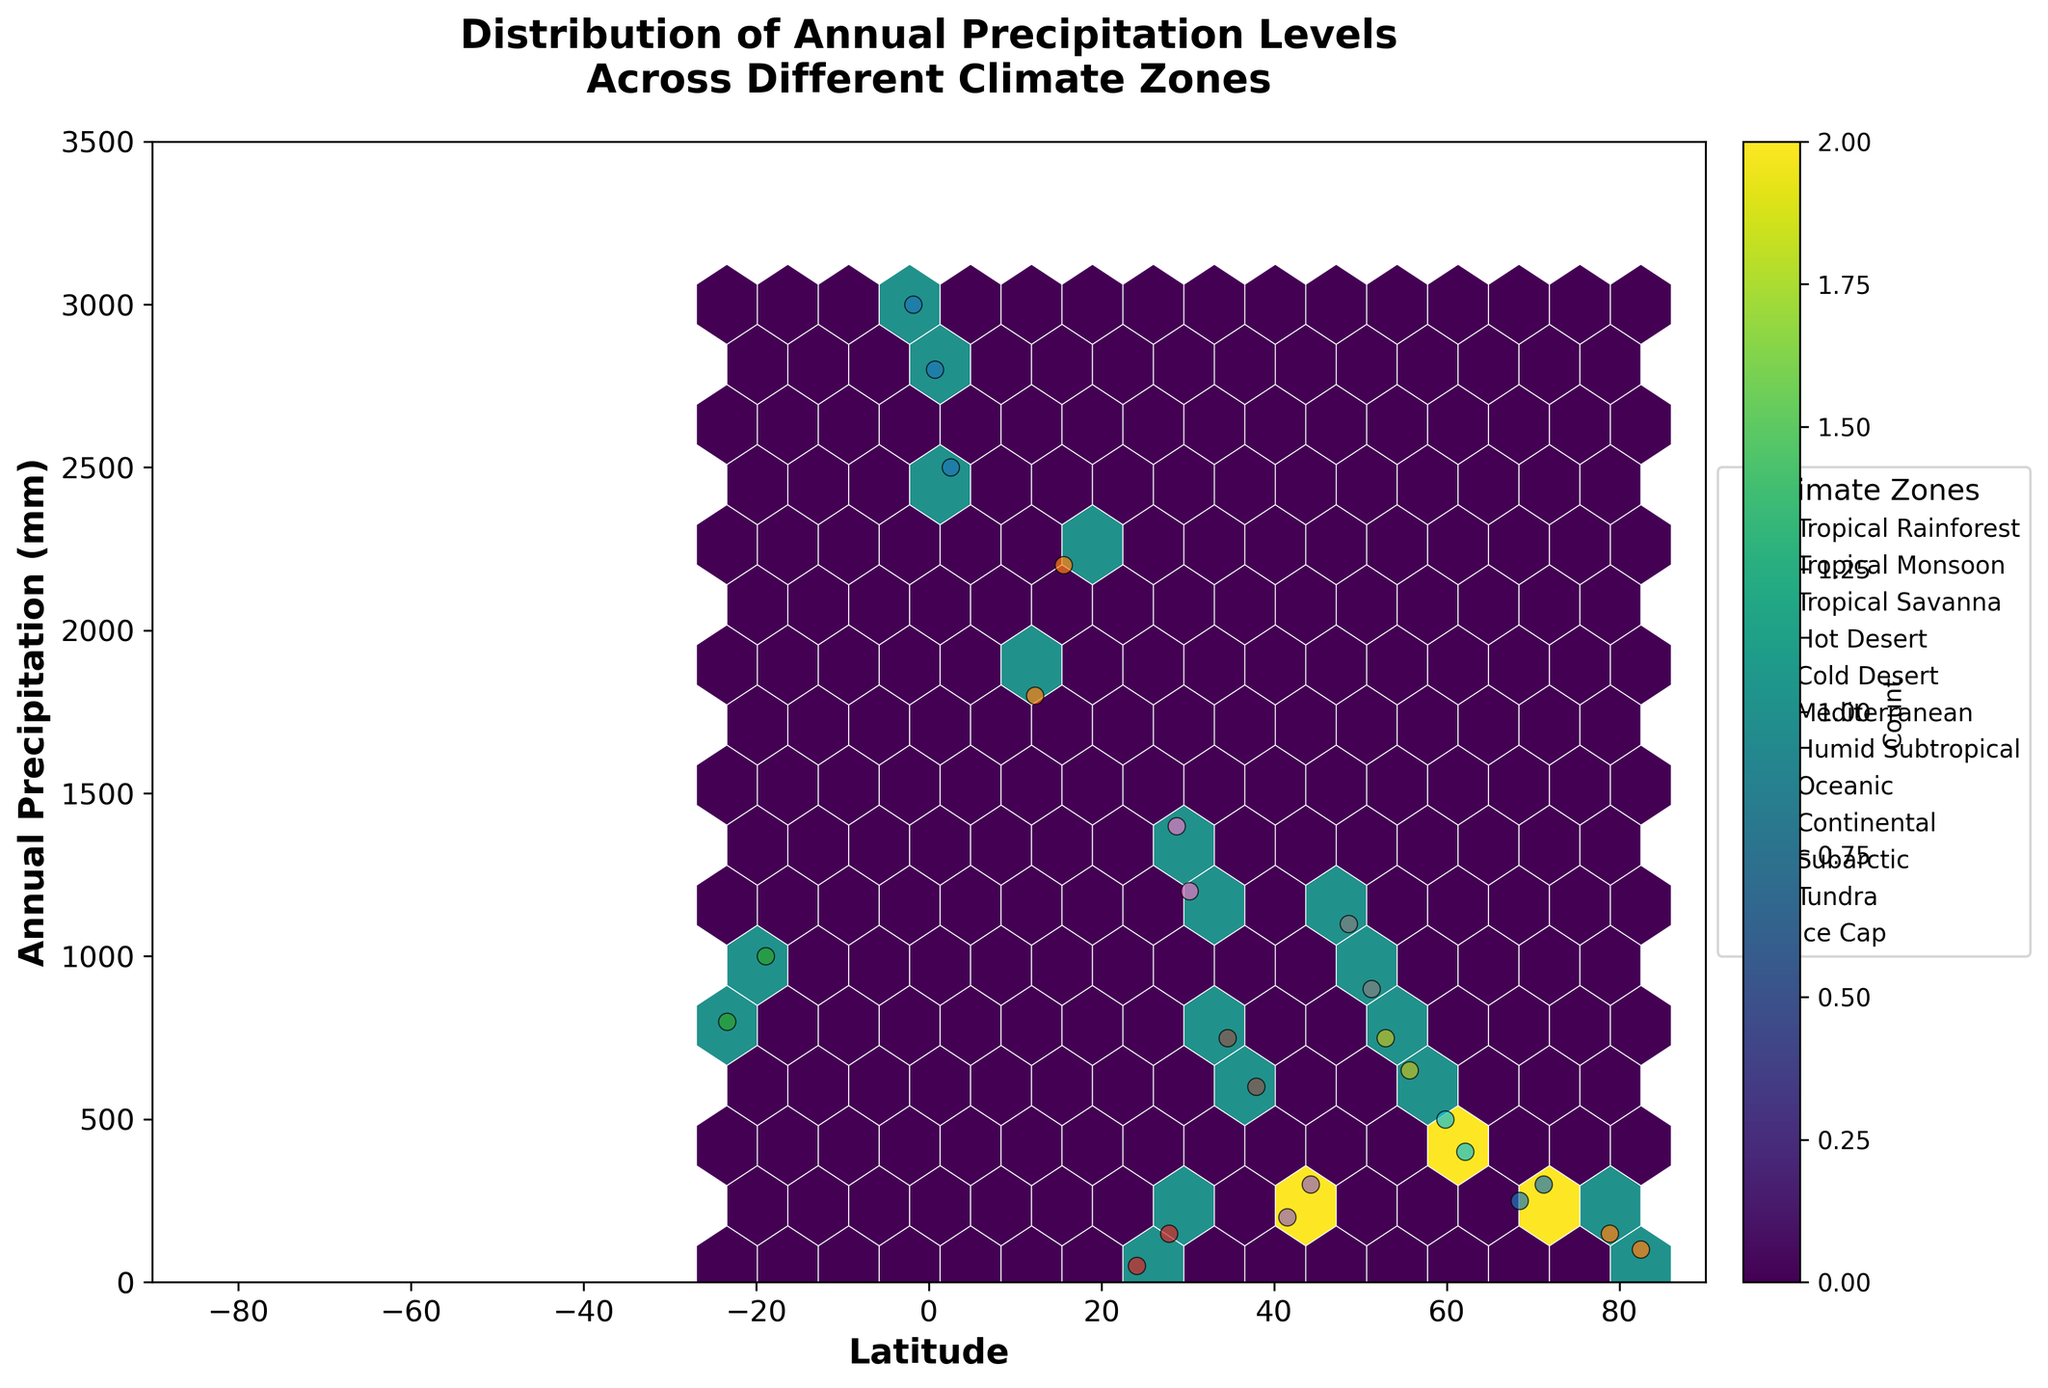What is the title of the plot? The title of the plot is usually found at the top of the figure. It provides a summary of the content being visualized.
Answer: Distribution of Annual Precipitation Levels Across Different Climate Zones What are the labels for the x-axis and y-axis? The x-axis and y-axis labels are typically found beside the respective axis, representing the dimensions of the data.
Answer: Latitude, Annual Precipitation (mm) How many climate zones are represented in the figure? The legend beside the chart lists all the unique climate zones present in the dataset. By counting the different entries listed, we can determine the number of climate zones.
Answer: 10 Which climate zone has the highest overall annual precipitation levels? By observing the scatter plots, we see which points reach the highest on the y-axis (Annual Precipitation). Checking the legend helps to identify the respective climate zone.
Answer: Tropical Rainforest What is the range of latitude covered by the data points in the Hot Desert climate zone? The data points for Hot Desert can be identified in the legend, and by looking at their x-axis positions, we determine the latitude span.
Answer: 24.1 to 27.8 What is the average annual precipitation level for the Subarctic zone? Add the precipitation values for Subarctic (400 + 500) and divide by the number of points to find the average.
Answer: (400 + 500) / 2 = 450 mm Which climate zone has the most tightly clustered annual precipitation values? By examining the hexbin density, we can infer which climate zone's data points are closest together on the y-axis. Review the scatter plot for tightly grouped distributions.
Answer: Tundra Are there any climate zones without overlapping hexbin points? Look for climate zones that have unique regions in the hexbin plot and do not overlap with others visually. Compare scatter plot positions for clarity.
Answer: Yes Compare the highest annual precipitation in the Mediterranean zone to the Cold Desert zone. The highest points in each zone can be identified using the scatter plot's y-axis positions. Amount in Mediterranean is 750 mm, in Cold Desert is 300 mm.
Answer: 750 mm (Mediterranean) vs 300 mm (Cold Desert) 